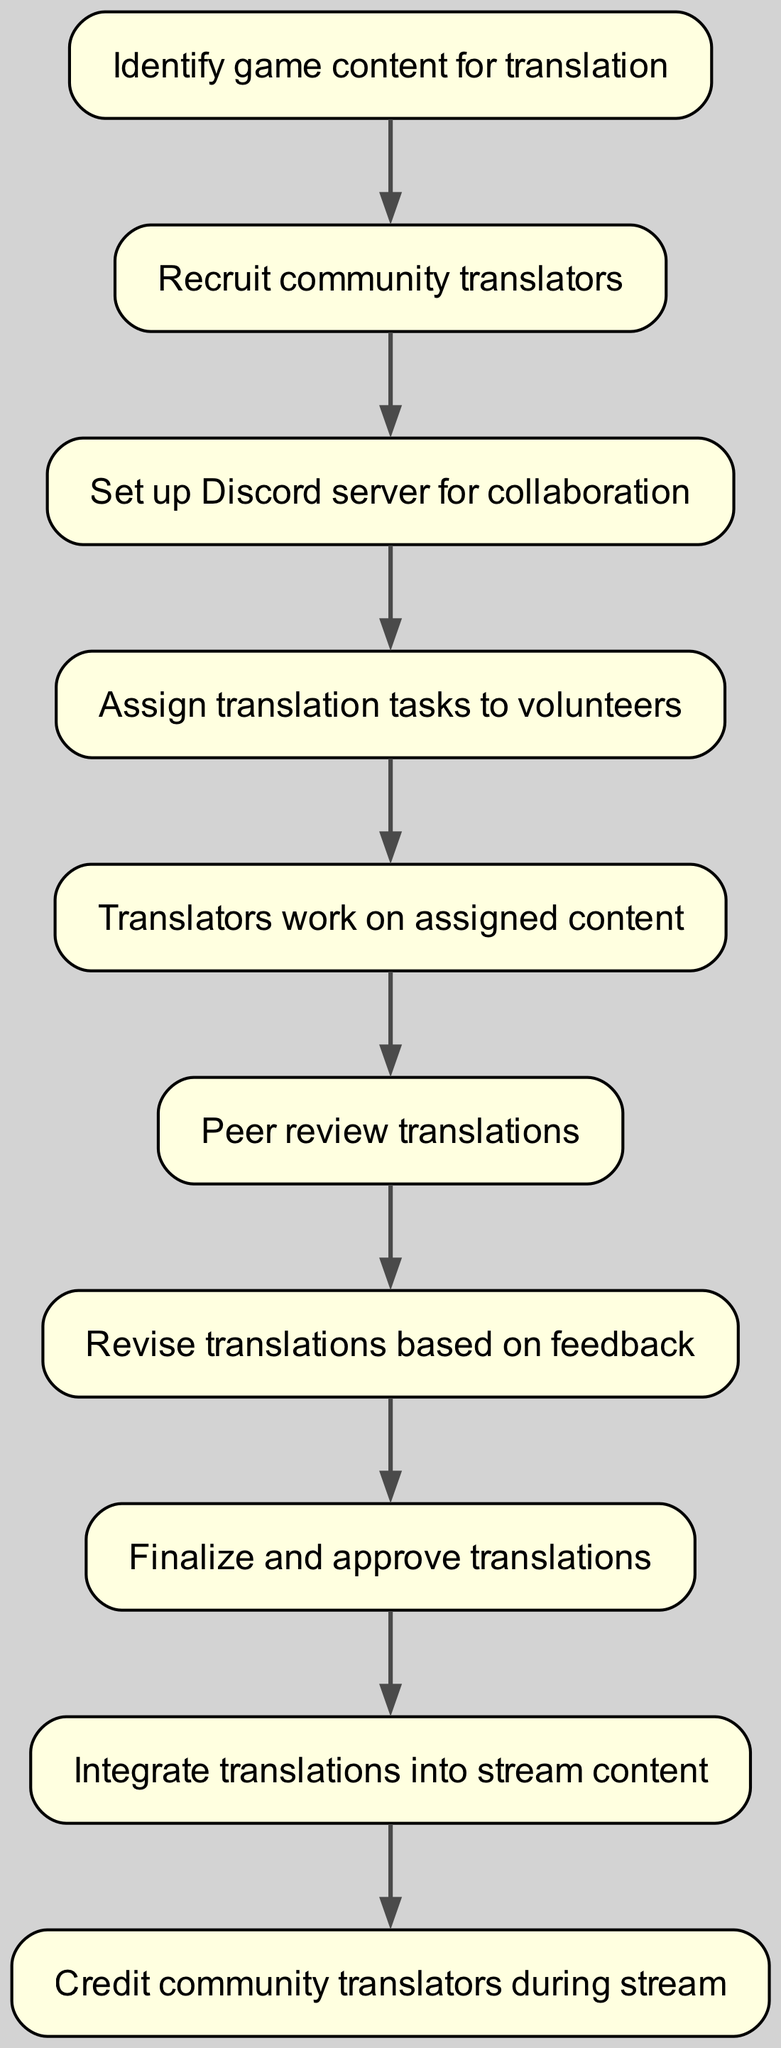What is the first step in the translation process? The diagram starts with the node labeled "Identify game content for translation," indicating that this is the initial step.
Answer: Identify game content for translation How many nodes does the diagram contain? By counting each unique step in the diagram, there are 10 nodes listed from "Identify game content for translation" to "Credit community translators during stream."
Answer: 10 What follows after assigning translation tasks? The process flows from "Assign translation tasks to volunteers" directly to "Translators work on assigned content," showing that this step immediately follows task assignment.
Answer: Translators work on assigned content Which node comes after the peer review step? The diagram indicates that "Revise translations based on feedback" follows "Peer review translations," creating a direct connection between these two steps.
Answer: Revise translations based on feedback How many connections or edges are present in the diagram? By examining the arrows that represent the relationships between nodes, there are 9 connections throughout the flow chart.
Answer: 9 What is the last step of the translation process? The final node in the diagram is "Credit community translators during stream," indicating that this is the last step to be performed.
Answer: Credit community translators during stream Which step is directly connected to the "Integrate translations into stream content"? The diagram shows that "Finalize and approve translations" is the immediate predecessor to "Integrate translations into stream content," establishing a clear order.
Answer: Finalize and approve translations What step comes before recruiting community translators? "Identify game content for translation" is the step that precedes the recruitment of community translators as shown in the flow.
Answer: Identify game content for translation Is there a step for revising translations? Yes, the diagram includes a specific step labeled "Revise translations based on feedback," indicating that revisions are part of the process.
Answer: Revise translations based on feedback 